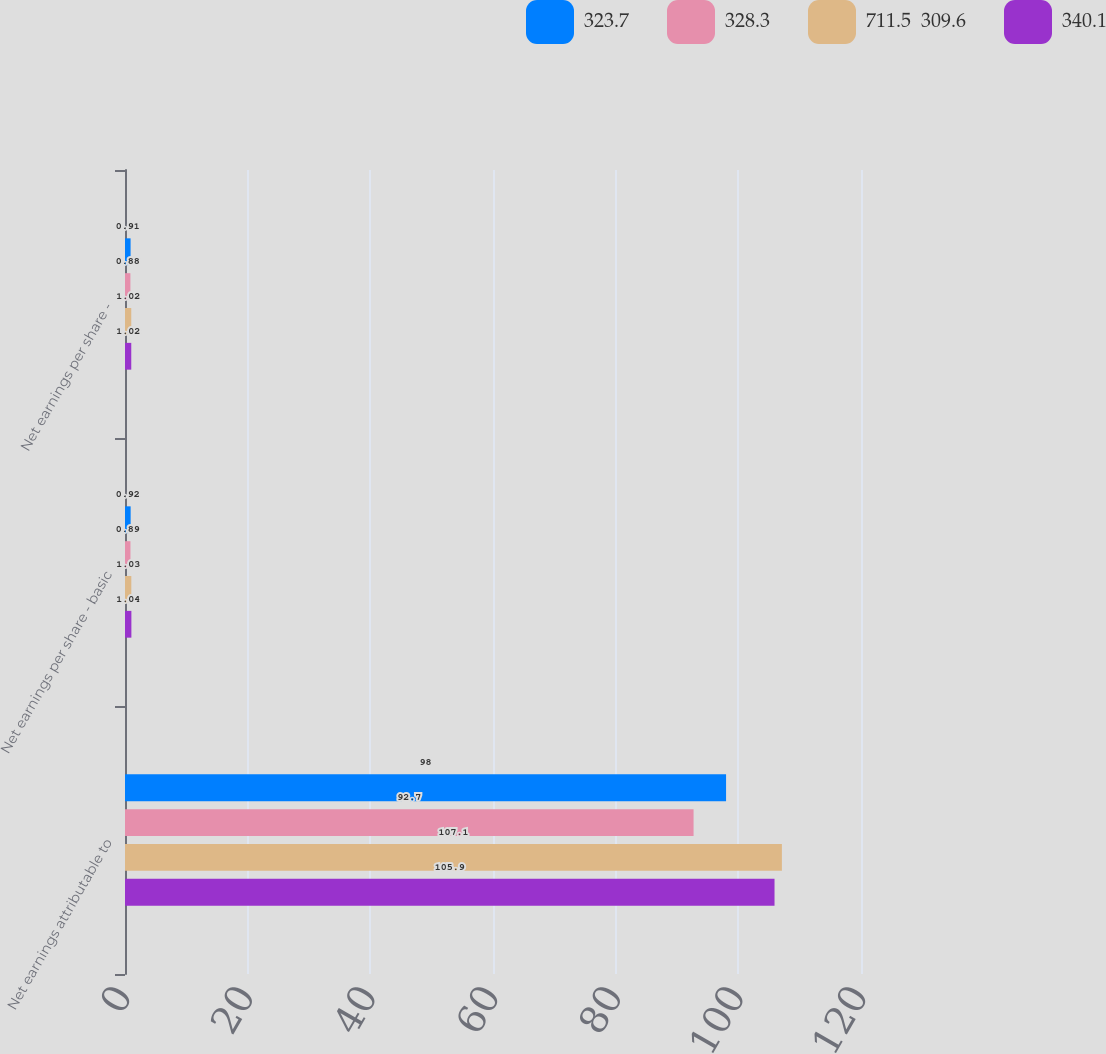Convert chart to OTSL. <chart><loc_0><loc_0><loc_500><loc_500><stacked_bar_chart><ecel><fcel>Net earnings attributable to<fcel>Net earnings per share - basic<fcel>Net earnings per share -<nl><fcel>323.7<fcel>98<fcel>0.92<fcel>0.91<nl><fcel>328.3<fcel>92.7<fcel>0.89<fcel>0.88<nl><fcel>711.5  309.6<fcel>107.1<fcel>1.03<fcel>1.02<nl><fcel>340.1<fcel>105.9<fcel>1.04<fcel>1.02<nl></chart> 